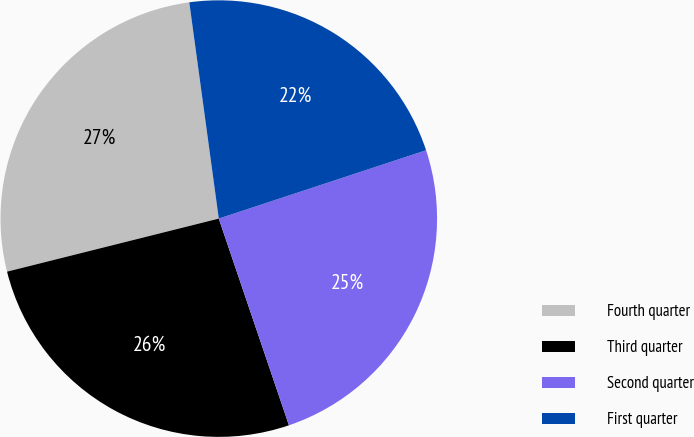Convert chart. <chart><loc_0><loc_0><loc_500><loc_500><pie_chart><fcel>Fourth quarter<fcel>Third quarter<fcel>Second quarter<fcel>First quarter<nl><fcel>26.75%<fcel>26.3%<fcel>24.86%<fcel>22.09%<nl></chart> 